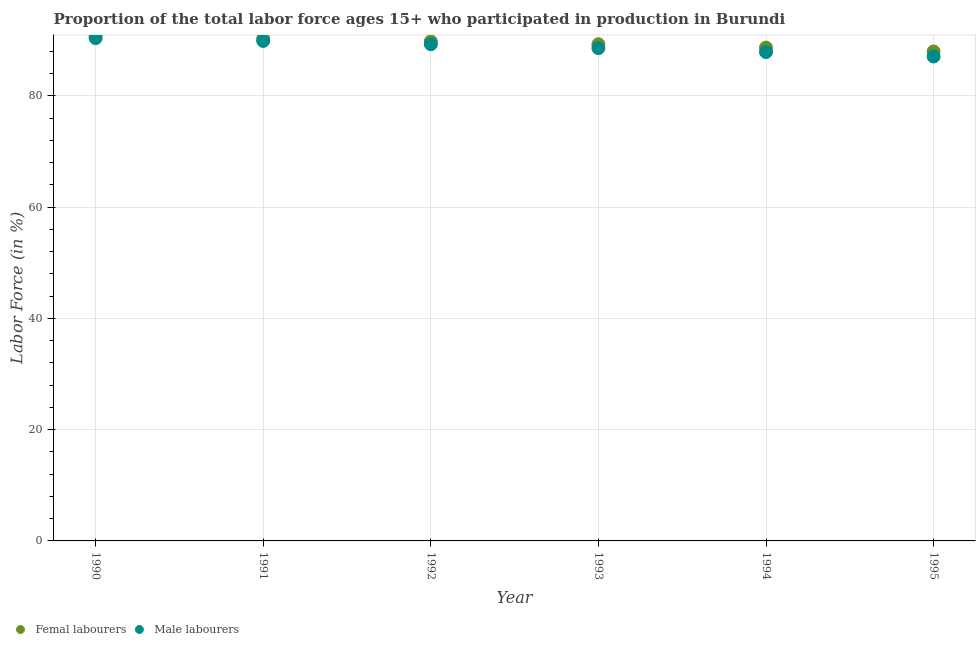What is the percentage of female labor force in 1993?
Give a very brief answer. 89.3. Across all years, what is the maximum percentage of female labor force?
Keep it short and to the point. 90.8. In which year was the percentage of female labor force maximum?
Keep it short and to the point. 1990. What is the total percentage of male labour force in the graph?
Offer a very short reply. 533.2. What is the difference between the percentage of male labour force in 1990 and that in 1992?
Provide a succinct answer. 1.1. What is the difference between the percentage of female labor force in 1990 and the percentage of male labour force in 1992?
Offer a very short reply. 1.5. What is the average percentage of female labor force per year?
Keep it short and to the point. 89.48. In the year 1991, what is the difference between the percentage of female labor force and percentage of male labour force?
Offer a very short reply. 0.4. In how many years, is the percentage of female labor force greater than 44 %?
Give a very brief answer. 6. What is the ratio of the percentage of female labor force in 1992 to that in 1993?
Your answer should be compact. 1.01. Is the percentage of male labour force in 1991 less than that in 1995?
Provide a succinct answer. No. Is the difference between the percentage of male labour force in 1994 and 1995 greater than the difference between the percentage of female labor force in 1994 and 1995?
Keep it short and to the point. Yes. What is the difference between the highest and the lowest percentage of female labor force?
Keep it short and to the point. 2.8. Is the sum of the percentage of male labour force in 1991 and 1992 greater than the maximum percentage of female labor force across all years?
Your response must be concise. Yes. Does the percentage of male labour force monotonically increase over the years?
Your response must be concise. No. How many dotlines are there?
Your answer should be compact. 2. How many years are there in the graph?
Keep it short and to the point. 6. Are the values on the major ticks of Y-axis written in scientific E-notation?
Offer a very short reply. No. Does the graph contain any zero values?
Ensure brevity in your answer.  No. How are the legend labels stacked?
Ensure brevity in your answer.  Horizontal. What is the title of the graph?
Your answer should be compact. Proportion of the total labor force ages 15+ who participated in production in Burundi. Does "Secondary" appear as one of the legend labels in the graph?
Your answer should be very brief. No. What is the label or title of the X-axis?
Offer a terse response. Year. What is the label or title of the Y-axis?
Make the answer very short. Labor Force (in %). What is the Labor Force (in %) in Femal labourers in 1990?
Your answer should be very brief. 90.8. What is the Labor Force (in %) of Male labourers in 1990?
Keep it short and to the point. 90.4. What is the Labor Force (in %) of Femal labourers in 1991?
Provide a succinct answer. 90.3. What is the Labor Force (in %) in Male labourers in 1991?
Your response must be concise. 89.9. What is the Labor Force (in %) of Femal labourers in 1992?
Give a very brief answer. 89.8. What is the Labor Force (in %) in Male labourers in 1992?
Ensure brevity in your answer.  89.3. What is the Labor Force (in %) in Femal labourers in 1993?
Your answer should be very brief. 89.3. What is the Labor Force (in %) in Male labourers in 1993?
Give a very brief answer. 88.6. What is the Labor Force (in %) in Femal labourers in 1994?
Offer a terse response. 88.7. What is the Labor Force (in %) of Male labourers in 1994?
Provide a succinct answer. 87.9. What is the Labor Force (in %) of Femal labourers in 1995?
Provide a short and direct response. 88. What is the Labor Force (in %) of Male labourers in 1995?
Ensure brevity in your answer.  87.1. Across all years, what is the maximum Labor Force (in %) in Femal labourers?
Make the answer very short. 90.8. Across all years, what is the maximum Labor Force (in %) in Male labourers?
Your answer should be very brief. 90.4. Across all years, what is the minimum Labor Force (in %) in Femal labourers?
Offer a very short reply. 88. Across all years, what is the minimum Labor Force (in %) of Male labourers?
Keep it short and to the point. 87.1. What is the total Labor Force (in %) in Femal labourers in the graph?
Your response must be concise. 536.9. What is the total Labor Force (in %) in Male labourers in the graph?
Offer a very short reply. 533.2. What is the difference between the Labor Force (in %) in Femal labourers in 1990 and that in 1991?
Provide a succinct answer. 0.5. What is the difference between the Labor Force (in %) in Male labourers in 1990 and that in 1991?
Ensure brevity in your answer.  0.5. What is the difference between the Labor Force (in %) of Femal labourers in 1990 and that in 1993?
Provide a short and direct response. 1.5. What is the difference between the Labor Force (in %) in Male labourers in 1990 and that in 1993?
Provide a short and direct response. 1.8. What is the difference between the Labor Force (in %) in Male labourers in 1990 and that in 1994?
Your answer should be compact. 2.5. What is the difference between the Labor Force (in %) of Male labourers in 1990 and that in 1995?
Provide a succinct answer. 3.3. What is the difference between the Labor Force (in %) in Male labourers in 1991 and that in 1992?
Offer a terse response. 0.6. What is the difference between the Labor Force (in %) in Male labourers in 1991 and that in 1993?
Give a very brief answer. 1.3. What is the difference between the Labor Force (in %) in Femal labourers in 1991 and that in 1994?
Ensure brevity in your answer.  1.6. What is the difference between the Labor Force (in %) of Femal labourers in 1991 and that in 1995?
Provide a succinct answer. 2.3. What is the difference between the Labor Force (in %) in Male labourers in 1991 and that in 1995?
Give a very brief answer. 2.8. What is the difference between the Labor Force (in %) in Male labourers in 1992 and that in 1993?
Offer a terse response. 0.7. What is the difference between the Labor Force (in %) of Femal labourers in 1992 and that in 1994?
Your answer should be compact. 1.1. What is the difference between the Labor Force (in %) in Femal labourers in 1992 and that in 1995?
Offer a terse response. 1.8. What is the difference between the Labor Force (in %) in Male labourers in 1992 and that in 1995?
Offer a very short reply. 2.2. What is the difference between the Labor Force (in %) in Femal labourers in 1994 and that in 1995?
Offer a terse response. 0.7. What is the difference between the Labor Force (in %) of Male labourers in 1994 and that in 1995?
Provide a short and direct response. 0.8. What is the difference between the Labor Force (in %) in Femal labourers in 1990 and the Labor Force (in %) in Male labourers in 1991?
Offer a terse response. 0.9. What is the difference between the Labor Force (in %) of Femal labourers in 1990 and the Labor Force (in %) of Male labourers in 1993?
Offer a terse response. 2.2. What is the difference between the Labor Force (in %) of Femal labourers in 1990 and the Labor Force (in %) of Male labourers in 1995?
Ensure brevity in your answer.  3.7. What is the difference between the Labor Force (in %) in Femal labourers in 1991 and the Labor Force (in %) in Male labourers in 1995?
Provide a short and direct response. 3.2. What is the difference between the Labor Force (in %) of Femal labourers in 1992 and the Labor Force (in %) of Male labourers in 1993?
Your response must be concise. 1.2. What is the difference between the Labor Force (in %) in Femal labourers in 1992 and the Labor Force (in %) in Male labourers in 1994?
Offer a terse response. 1.9. What is the difference between the Labor Force (in %) of Femal labourers in 1993 and the Labor Force (in %) of Male labourers in 1994?
Give a very brief answer. 1.4. What is the difference between the Labor Force (in %) of Femal labourers in 1993 and the Labor Force (in %) of Male labourers in 1995?
Ensure brevity in your answer.  2.2. What is the difference between the Labor Force (in %) of Femal labourers in 1994 and the Labor Force (in %) of Male labourers in 1995?
Give a very brief answer. 1.6. What is the average Labor Force (in %) of Femal labourers per year?
Your response must be concise. 89.48. What is the average Labor Force (in %) of Male labourers per year?
Offer a very short reply. 88.87. In the year 1990, what is the difference between the Labor Force (in %) of Femal labourers and Labor Force (in %) of Male labourers?
Ensure brevity in your answer.  0.4. In the year 1991, what is the difference between the Labor Force (in %) of Femal labourers and Labor Force (in %) of Male labourers?
Your answer should be very brief. 0.4. In the year 1995, what is the difference between the Labor Force (in %) of Femal labourers and Labor Force (in %) of Male labourers?
Offer a very short reply. 0.9. What is the ratio of the Labor Force (in %) of Male labourers in 1990 to that in 1991?
Provide a short and direct response. 1.01. What is the ratio of the Labor Force (in %) in Femal labourers in 1990 to that in 1992?
Keep it short and to the point. 1.01. What is the ratio of the Labor Force (in %) in Male labourers in 1990 to that in 1992?
Ensure brevity in your answer.  1.01. What is the ratio of the Labor Force (in %) of Femal labourers in 1990 to that in 1993?
Make the answer very short. 1.02. What is the ratio of the Labor Force (in %) of Male labourers in 1990 to that in 1993?
Keep it short and to the point. 1.02. What is the ratio of the Labor Force (in %) in Femal labourers in 1990 to that in 1994?
Provide a succinct answer. 1.02. What is the ratio of the Labor Force (in %) of Male labourers in 1990 to that in 1994?
Your response must be concise. 1.03. What is the ratio of the Labor Force (in %) in Femal labourers in 1990 to that in 1995?
Your answer should be very brief. 1.03. What is the ratio of the Labor Force (in %) in Male labourers in 1990 to that in 1995?
Provide a short and direct response. 1.04. What is the ratio of the Labor Force (in %) in Femal labourers in 1991 to that in 1992?
Your response must be concise. 1.01. What is the ratio of the Labor Force (in %) in Male labourers in 1991 to that in 1992?
Your answer should be very brief. 1.01. What is the ratio of the Labor Force (in %) in Femal labourers in 1991 to that in 1993?
Give a very brief answer. 1.01. What is the ratio of the Labor Force (in %) in Male labourers in 1991 to that in 1993?
Provide a succinct answer. 1.01. What is the ratio of the Labor Force (in %) of Femal labourers in 1991 to that in 1994?
Provide a short and direct response. 1.02. What is the ratio of the Labor Force (in %) in Male labourers in 1991 to that in 1994?
Your answer should be compact. 1.02. What is the ratio of the Labor Force (in %) in Femal labourers in 1991 to that in 1995?
Ensure brevity in your answer.  1.03. What is the ratio of the Labor Force (in %) of Male labourers in 1991 to that in 1995?
Your answer should be very brief. 1.03. What is the ratio of the Labor Force (in %) of Femal labourers in 1992 to that in 1993?
Give a very brief answer. 1.01. What is the ratio of the Labor Force (in %) in Male labourers in 1992 to that in 1993?
Offer a terse response. 1.01. What is the ratio of the Labor Force (in %) in Femal labourers in 1992 to that in 1994?
Make the answer very short. 1.01. What is the ratio of the Labor Force (in %) of Male labourers in 1992 to that in 1994?
Offer a very short reply. 1.02. What is the ratio of the Labor Force (in %) of Femal labourers in 1992 to that in 1995?
Give a very brief answer. 1.02. What is the ratio of the Labor Force (in %) in Male labourers in 1992 to that in 1995?
Keep it short and to the point. 1.03. What is the ratio of the Labor Force (in %) of Femal labourers in 1993 to that in 1994?
Your answer should be compact. 1.01. What is the ratio of the Labor Force (in %) in Femal labourers in 1993 to that in 1995?
Provide a short and direct response. 1.01. What is the ratio of the Labor Force (in %) of Male labourers in 1993 to that in 1995?
Provide a succinct answer. 1.02. What is the ratio of the Labor Force (in %) of Male labourers in 1994 to that in 1995?
Make the answer very short. 1.01. What is the difference between the highest and the second highest Labor Force (in %) of Male labourers?
Provide a succinct answer. 0.5. What is the difference between the highest and the lowest Labor Force (in %) of Femal labourers?
Keep it short and to the point. 2.8. What is the difference between the highest and the lowest Labor Force (in %) in Male labourers?
Give a very brief answer. 3.3. 